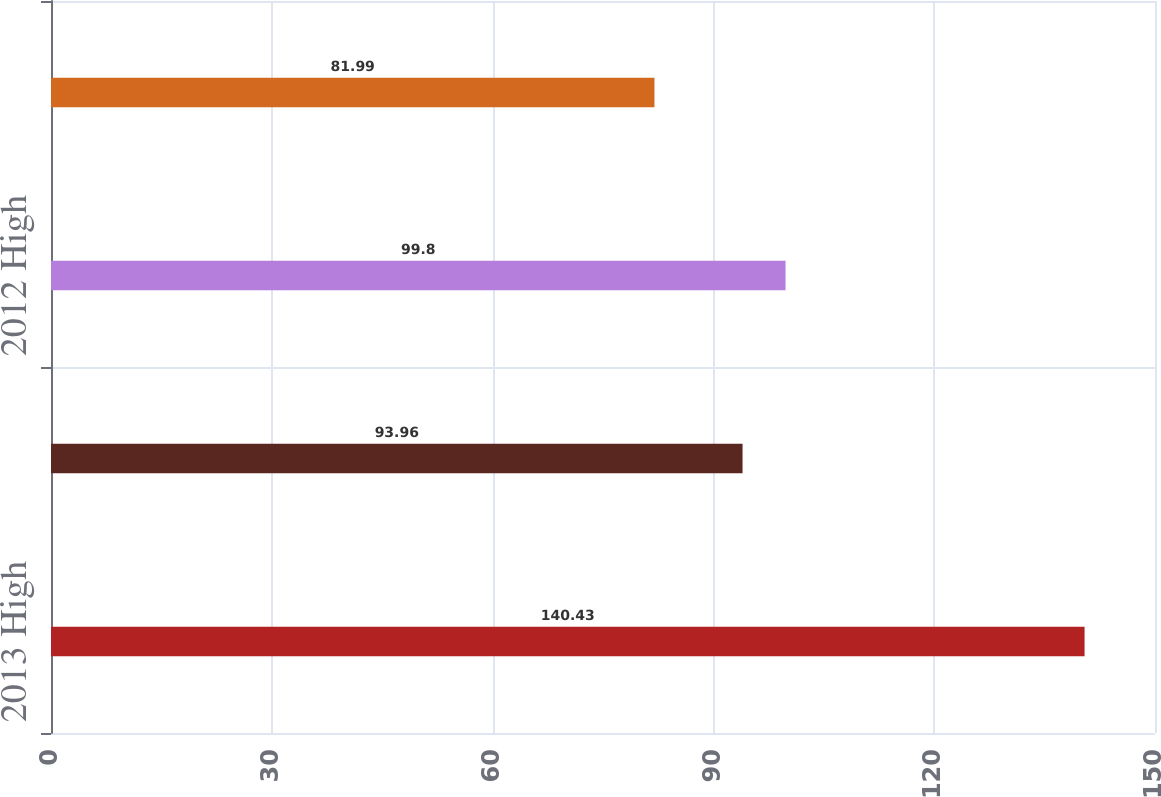Convert chart to OTSL. <chart><loc_0><loc_0><loc_500><loc_500><bar_chart><fcel>2013 High<fcel>2013 Low<fcel>2012 High<fcel>2012 Low<nl><fcel>140.43<fcel>93.96<fcel>99.8<fcel>81.99<nl></chart> 